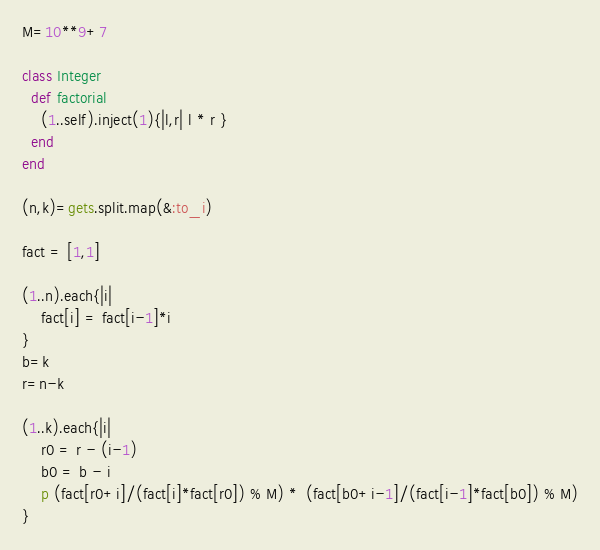<code> <loc_0><loc_0><loc_500><loc_500><_Ruby_>M=10**9+7

class Integer
  def factorial
    (1..self).inject(1){|l,r| l * r }
  end
end

(n,k)=gets.split.map(&:to_i)

fact = [1,1]

(1..n).each{|i|
    fact[i] = fact[i-1]*i
}
b=k
r=n-k

(1..k).each{|i|
    r0 = r - (i-1)
    b0 = b - i
    p (fact[r0+i]/(fact[i]*fact[r0]) % M) *  (fact[b0+i-1]/(fact[i-1]*fact[b0]) % M)
}</code> 